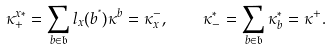<formula> <loc_0><loc_0><loc_500><loc_500>\kappa _ { + } ^ { x \ast } = \sum _ { b \in \mathfrak { b } } l _ { x } ( b ^ { ^ { * } } ) \kappa ^ { b } = \kappa _ { x } ^ { - } , \quad \kappa _ { - } ^ { \ast } = \sum _ { b \in \mathfrak { b } } \kappa _ { b } ^ { \ast } = \kappa ^ { + } .</formula> 